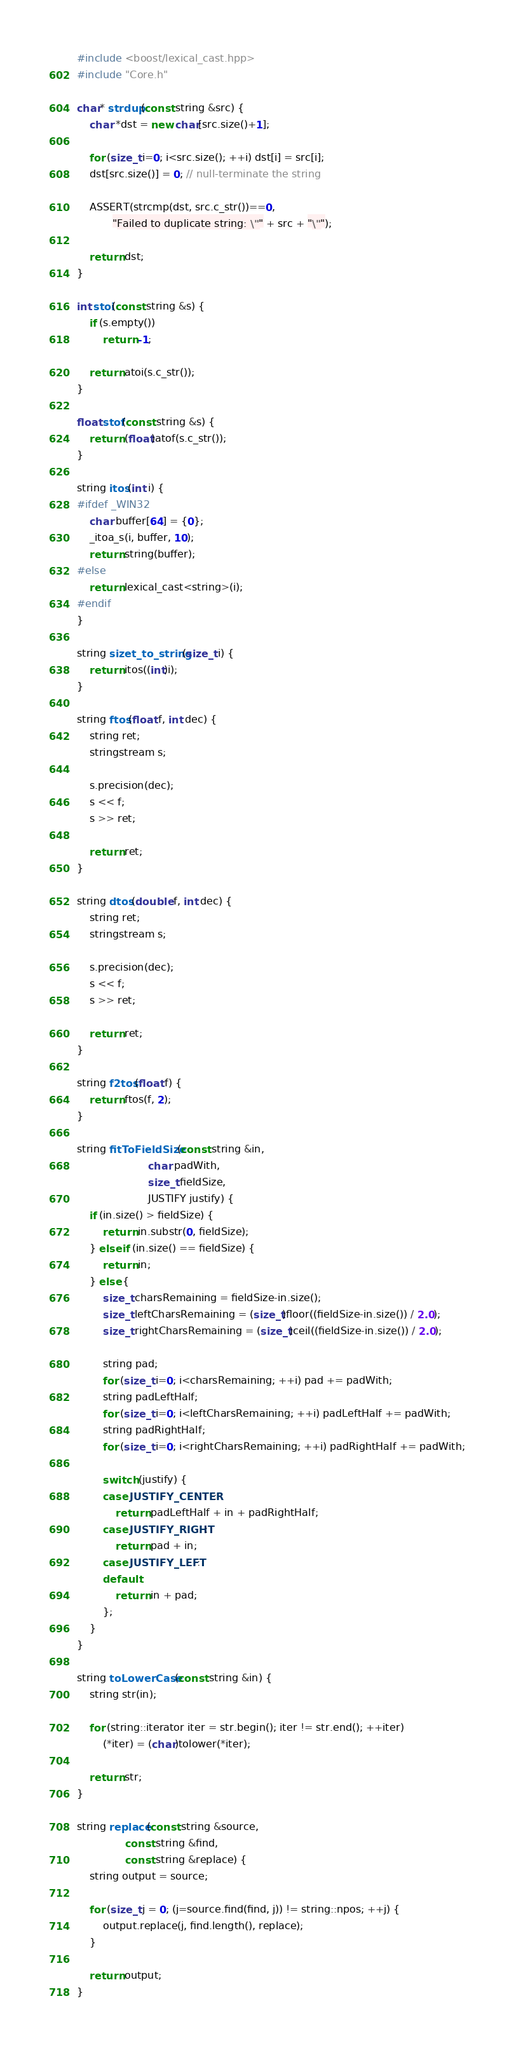<code> <loc_0><loc_0><loc_500><loc_500><_C++_>#include <boost/lexical_cast.hpp>
#include "Core.h"

char* strdup(const string &src) {
	char *dst = new char[src.size()+1];
	
	for (size_t i=0; i<src.size(); ++i) dst[i] = src[i];
	dst[src.size()] = 0; // null-terminate the string
	
	ASSERT(strcmp(dst, src.c_str())==0,
	       "Failed to duplicate string: \"" + src + "\"");
	       
	return dst;
}

int stoi(const string &s) {
	if (s.empty())
		return -1;
		
	return atoi(s.c_str());
}

float stof(const string &s) {
	return (float)atof(s.c_str());
}

string itos(int i) {
#ifdef _WIN32
	char buffer[64] = {0};
	_itoa_s(i, buffer, 10);
	return string(buffer);
#else
	return lexical_cast<string>(i);
#endif
}

string sizet_to_string(size_t i) {
	return itos((int)i);
}

string ftos(float f, int dec) {
	string ret;
	stringstream s;
	
	s.precision(dec);
	s << f;
	s >> ret;
	
	return ret;
}

string dtos(double f, int dec) {
	string ret;
	stringstream s;
	
	s.precision(dec);
	s << f;
	s >> ret;
	
	return ret;
}

string f2tos(float f) {
	return ftos(f, 2);
}

string fitToFieldSize(const string &in,
                      char padWith,
                      size_t fieldSize,
                      JUSTIFY justify) {
	if (in.size() > fieldSize) {
		return in.substr(0, fieldSize);
	} else if (in.size() == fieldSize) {
		return in;
	} else {
		size_t charsRemaining = fieldSize-in.size();
		size_t leftCharsRemaining = (size_t)floor((fieldSize-in.size()) / 2.0);
		size_t rightCharsRemaining = (size_t)ceil((fieldSize-in.size()) / 2.0);
		
		string pad;
		for (size_t i=0; i<charsRemaining; ++i) pad += padWith;
		string padLeftHalf;
		for (size_t i=0; i<leftCharsRemaining; ++i) padLeftHalf += padWith;
		string padRightHalf;
		for (size_t i=0; i<rightCharsRemaining; ++i) padRightHalf += padWith;
		
		switch (justify) {
		case JUSTIFY_CENTER:
			return padLeftHalf + in + padRightHalf;
		case JUSTIFY_RIGHT:
			return pad + in;
		case JUSTIFY_LEFT:
		default:
			return in + pad;
		};
	}
}

string toLowerCase(const string &in) {
	string str(in);
	
	for (string::iterator iter = str.begin(); iter != str.end(); ++iter)
		(*iter) = (char)tolower(*iter);
		
	return str;
}

string replace(const string &source,
               const string &find,
               const string &replace) {
	string output = source;
	
	for (size_t j = 0; (j=source.find(find, j)) != string::npos; ++j) {
		output.replace(j, find.length(), replace);
	}
	
	return output;
}
</code> 